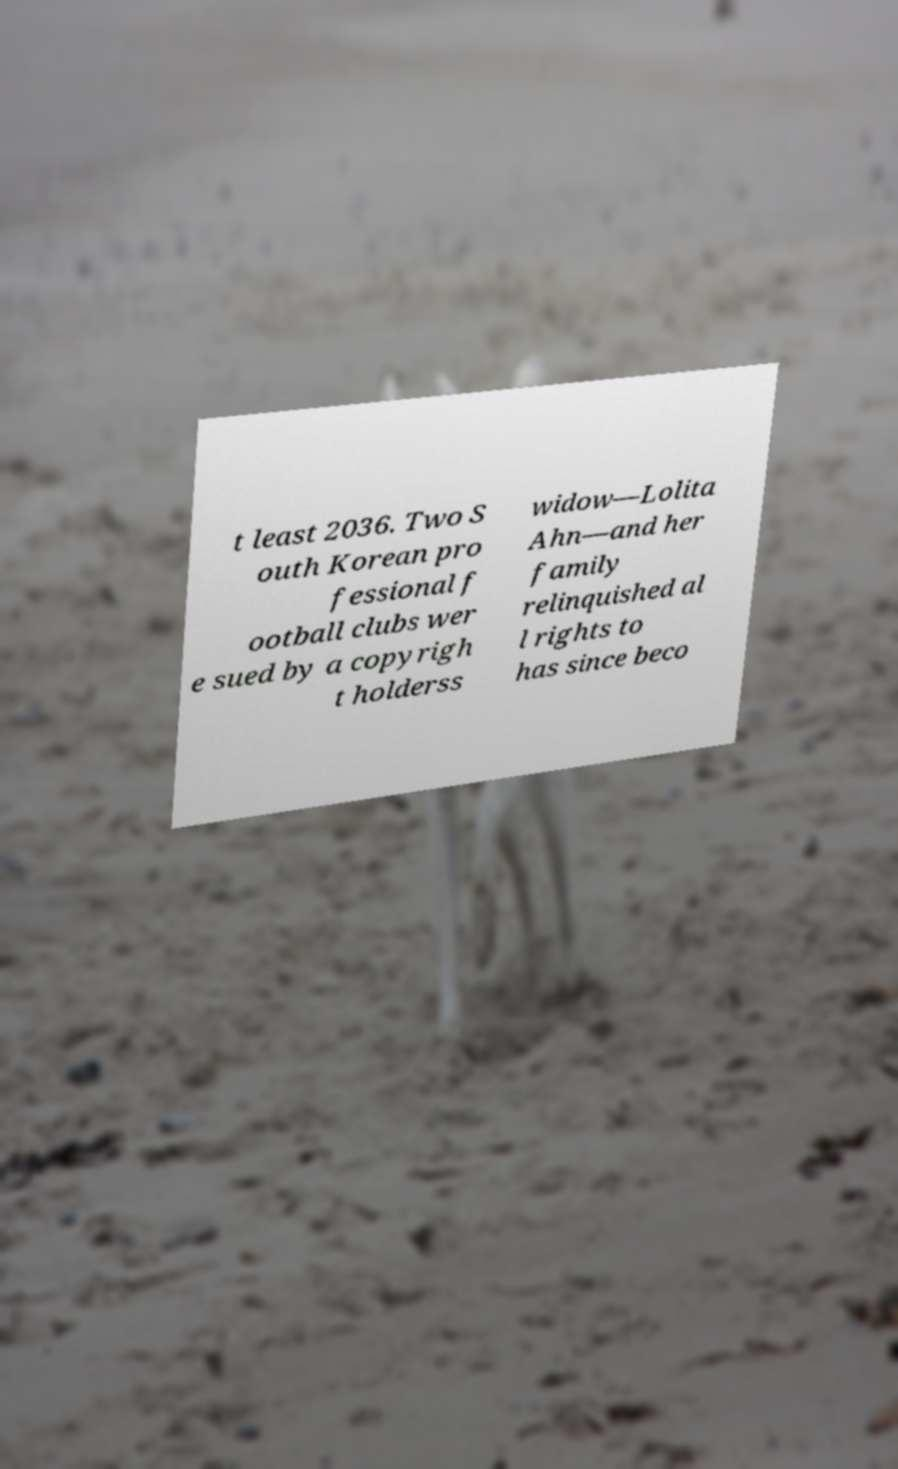I need the written content from this picture converted into text. Can you do that? t least 2036. Two S outh Korean pro fessional f ootball clubs wer e sued by a copyrigh t holderss widow—Lolita Ahn—and her family relinquished al l rights to has since beco 